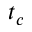Convert formula to latex. <formula><loc_0><loc_0><loc_500><loc_500>t _ { c }</formula> 